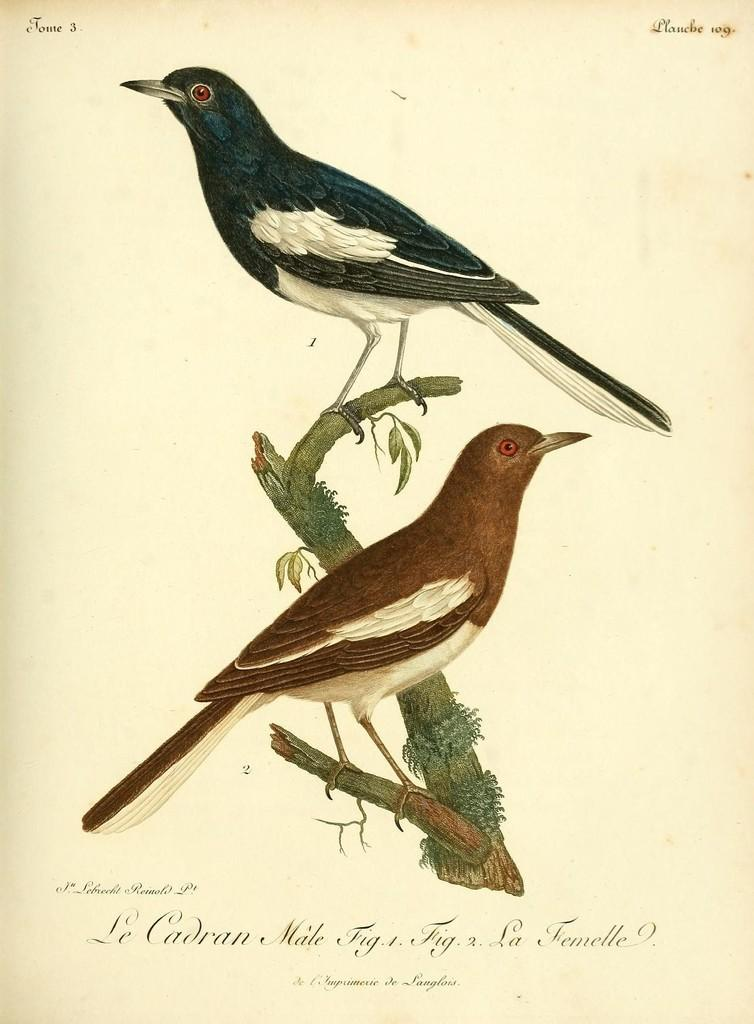What is the main subject of the paper in the image? The paper contains a drawing or image of two birds. How are the birds positioned in the drawing? The birds are depicted on a stem. What is the mass of the cream used to draw the birds on the paper? There is no cream mentioned or depicted in the image; the birds are drawn using a different medium, likely ink or pencil. 